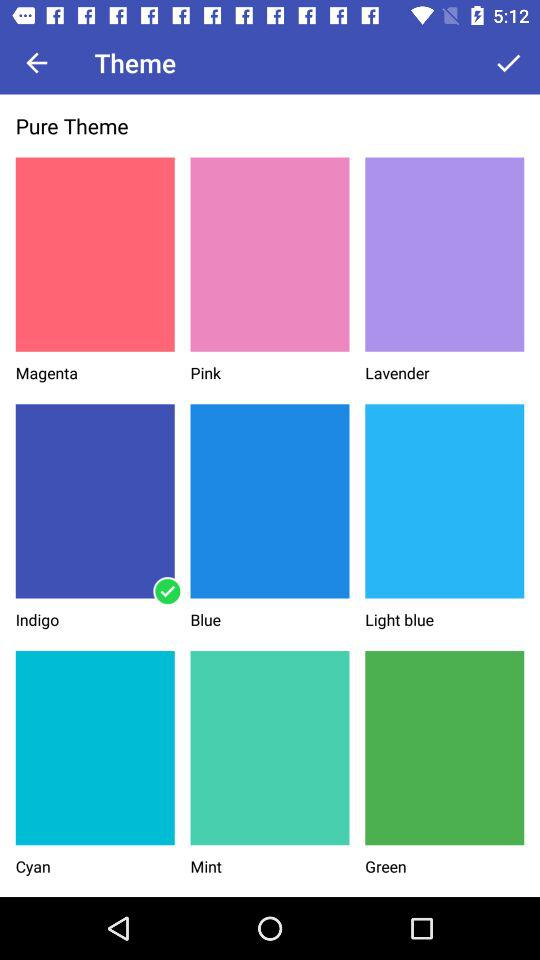Which option has been selected? The selected option is "Indigo". 